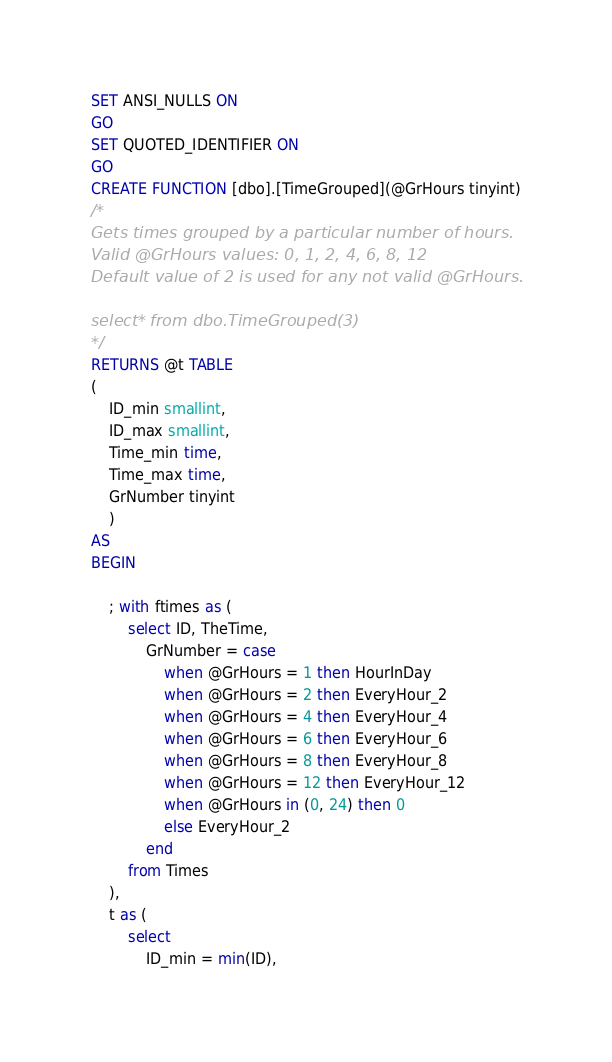<code> <loc_0><loc_0><loc_500><loc_500><_SQL_>SET ANSI_NULLS ON
GO
SET QUOTED_IDENTIFIER ON
GO
CREATE FUNCTION [dbo].[TimeGrouped](@GrHours tinyint)
/*
Gets times grouped by a particular number of hours.
Valid @GrHours values: 0, 1, 2, 4, 6, 8, 12
Default value of 2 is used for any not valid @GrHours.

select * from dbo.TimeGrouped(3)
*/
RETURNS @t TABLE 
(
	ID_min smallint, 
	ID_max smallint, 
	Time_min time, 
	Time_max time,
	GrNumber tinyint
	)
AS
BEGIN

	; with ftimes as (
		select ID, TheTime,
			GrNumber = case 
				when @GrHours = 1 then HourInDay
				when @GrHours = 2 then EveryHour_2
				when @GrHours = 4 then EveryHour_4
				when @GrHours = 6 then EveryHour_6
				when @GrHours = 8 then EveryHour_8
				when @GrHours = 12 then EveryHour_12
				when @GrHours in (0, 24) then 0
				else EveryHour_2
			end
		from Times
	),
	t as (
		select
			ID_min = min(ID),</code> 